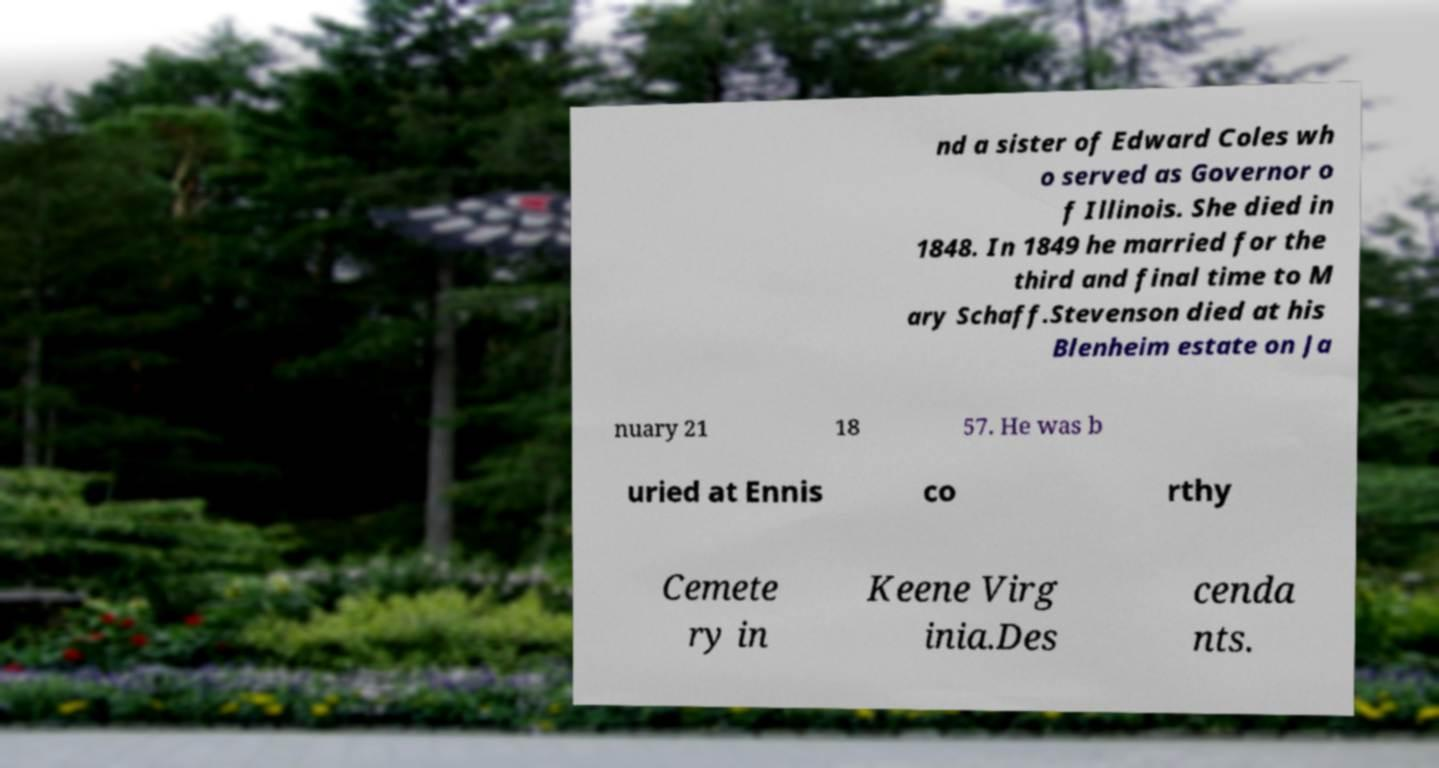For documentation purposes, I need the text within this image transcribed. Could you provide that? nd a sister of Edward Coles wh o served as Governor o f Illinois. She died in 1848. In 1849 he married for the third and final time to M ary Schaff.Stevenson died at his Blenheim estate on Ja nuary 21 18 57. He was b uried at Ennis co rthy Cemete ry in Keene Virg inia.Des cenda nts. 